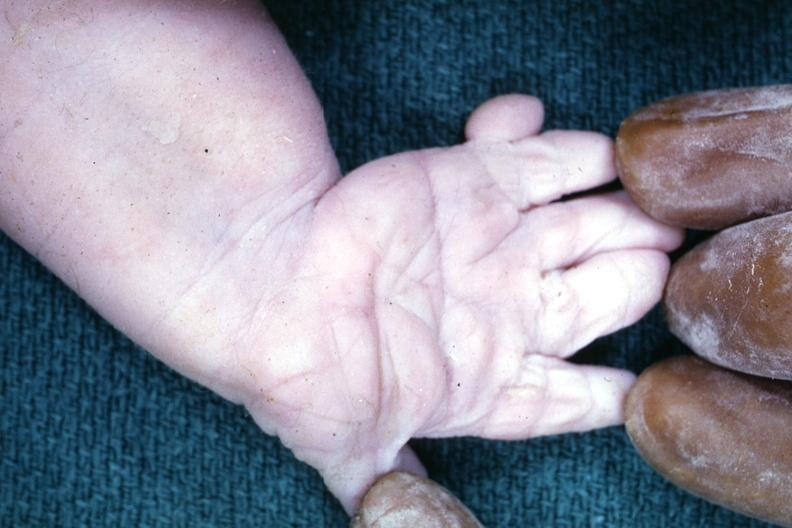what does this image show?
Answer the question using a single word or phrase. Simian crease 